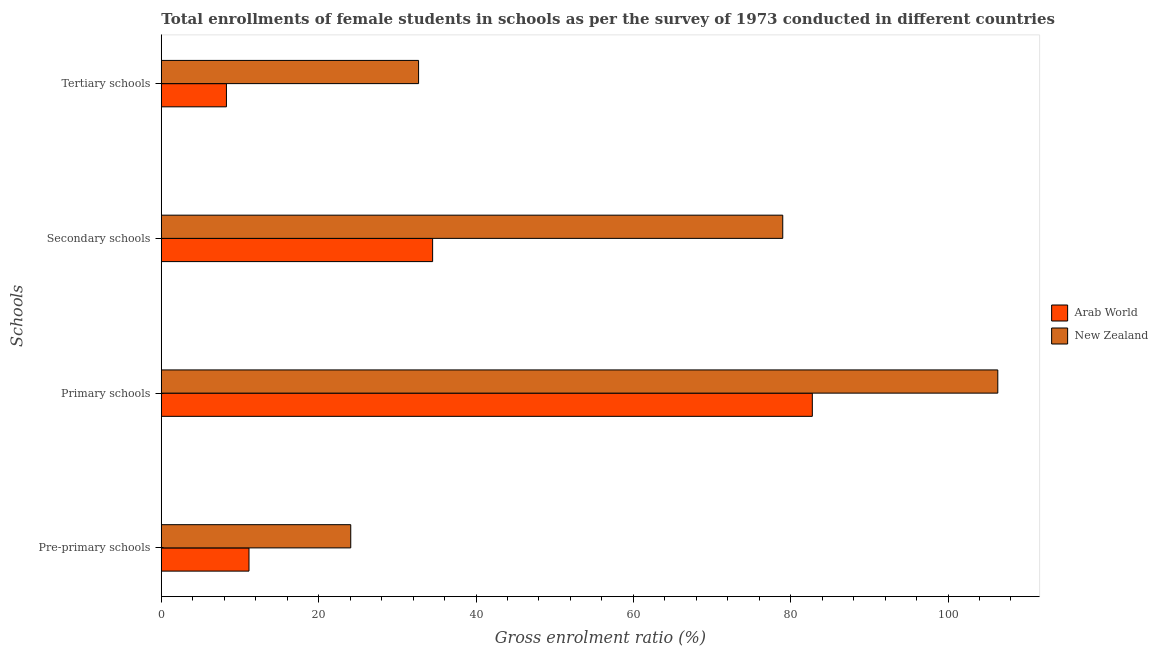Are the number of bars per tick equal to the number of legend labels?
Offer a very short reply. Yes. How many bars are there on the 4th tick from the top?
Your answer should be very brief. 2. What is the label of the 1st group of bars from the top?
Your answer should be compact. Tertiary schools. What is the gross enrolment ratio(female) in secondary schools in New Zealand?
Ensure brevity in your answer.  78.99. Across all countries, what is the maximum gross enrolment ratio(female) in primary schools?
Your response must be concise. 106.32. Across all countries, what is the minimum gross enrolment ratio(female) in secondary schools?
Keep it short and to the point. 34.49. In which country was the gross enrolment ratio(female) in tertiary schools maximum?
Your answer should be very brief. New Zealand. In which country was the gross enrolment ratio(female) in primary schools minimum?
Give a very brief answer. Arab World. What is the total gross enrolment ratio(female) in secondary schools in the graph?
Your answer should be compact. 113.47. What is the difference between the gross enrolment ratio(female) in primary schools in New Zealand and that in Arab World?
Your answer should be very brief. 23.57. What is the difference between the gross enrolment ratio(female) in tertiary schools in New Zealand and the gross enrolment ratio(female) in primary schools in Arab World?
Your answer should be compact. -50.05. What is the average gross enrolment ratio(female) in secondary schools per country?
Make the answer very short. 56.74. What is the difference between the gross enrolment ratio(female) in secondary schools and gross enrolment ratio(female) in pre-primary schools in Arab World?
Keep it short and to the point. 23.34. What is the ratio of the gross enrolment ratio(female) in pre-primary schools in Arab World to that in New Zealand?
Provide a short and direct response. 0.46. What is the difference between the highest and the second highest gross enrolment ratio(female) in pre-primary schools?
Provide a succinct answer. 12.93. What is the difference between the highest and the lowest gross enrolment ratio(female) in pre-primary schools?
Provide a short and direct response. 12.93. In how many countries, is the gross enrolment ratio(female) in tertiary schools greater than the average gross enrolment ratio(female) in tertiary schools taken over all countries?
Your response must be concise. 1. Is the sum of the gross enrolment ratio(female) in secondary schools in Arab World and New Zealand greater than the maximum gross enrolment ratio(female) in primary schools across all countries?
Keep it short and to the point. Yes. Is it the case that in every country, the sum of the gross enrolment ratio(female) in secondary schools and gross enrolment ratio(female) in tertiary schools is greater than the sum of gross enrolment ratio(female) in pre-primary schools and gross enrolment ratio(female) in primary schools?
Ensure brevity in your answer.  No. What does the 1st bar from the top in Primary schools represents?
Give a very brief answer. New Zealand. What does the 2nd bar from the bottom in Secondary schools represents?
Provide a short and direct response. New Zealand. Is it the case that in every country, the sum of the gross enrolment ratio(female) in pre-primary schools and gross enrolment ratio(female) in primary schools is greater than the gross enrolment ratio(female) in secondary schools?
Ensure brevity in your answer.  Yes. Are all the bars in the graph horizontal?
Your answer should be compact. Yes. Are the values on the major ticks of X-axis written in scientific E-notation?
Provide a short and direct response. No. How many legend labels are there?
Offer a very short reply. 2. How are the legend labels stacked?
Offer a very short reply. Vertical. What is the title of the graph?
Offer a very short reply. Total enrollments of female students in schools as per the survey of 1973 conducted in different countries. Does "Pacific island small states" appear as one of the legend labels in the graph?
Your answer should be compact. No. What is the label or title of the Y-axis?
Your response must be concise. Schools. What is the Gross enrolment ratio (%) in Arab World in Pre-primary schools?
Offer a very short reply. 11.15. What is the Gross enrolment ratio (%) in New Zealand in Pre-primary schools?
Make the answer very short. 24.08. What is the Gross enrolment ratio (%) in Arab World in Primary schools?
Your answer should be compact. 82.75. What is the Gross enrolment ratio (%) in New Zealand in Primary schools?
Offer a very short reply. 106.32. What is the Gross enrolment ratio (%) of Arab World in Secondary schools?
Make the answer very short. 34.49. What is the Gross enrolment ratio (%) of New Zealand in Secondary schools?
Offer a terse response. 78.99. What is the Gross enrolment ratio (%) of Arab World in Tertiary schools?
Your answer should be very brief. 8.28. What is the Gross enrolment ratio (%) of New Zealand in Tertiary schools?
Give a very brief answer. 32.7. Across all Schools, what is the maximum Gross enrolment ratio (%) in Arab World?
Provide a short and direct response. 82.75. Across all Schools, what is the maximum Gross enrolment ratio (%) of New Zealand?
Ensure brevity in your answer.  106.32. Across all Schools, what is the minimum Gross enrolment ratio (%) in Arab World?
Your answer should be compact. 8.28. Across all Schools, what is the minimum Gross enrolment ratio (%) in New Zealand?
Keep it short and to the point. 24.08. What is the total Gross enrolment ratio (%) in Arab World in the graph?
Make the answer very short. 136.66. What is the total Gross enrolment ratio (%) of New Zealand in the graph?
Provide a succinct answer. 242.09. What is the difference between the Gross enrolment ratio (%) of Arab World in Pre-primary schools and that in Primary schools?
Make the answer very short. -71.6. What is the difference between the Gross enrolment ratio (%) of New Zealand in Pre-primary schools and that in Primary schools?
Give a very brief answer. -82.24. What is the difference between the Gross enrolment ratio (%) of Arab World in Pre-primary schools and that in Secondary schools?
Your response must be concise. -23.34. What is the difference between the Gross enrolment ratio (%) in New Zealand in Pre-primary schools and that in Secondary schools?
Offer a very short reply. -54.91. What is the difference between the Gross enrolment ratio (%) in Arab World in Pre-primary schools and that in Tertiary schools?
Your response must be concise. 2.87. What is the difference between the Gross enrolment ratio (%) in New Zealand in Pre-primary schools and that in Tertiary schools?
Give a very brief answer. -8.62. What is the difference between the Gross enrolment ratio (%) of Arab World in Primary schools and that in Secondary schools?
Your answer should be compact. 48.26. What is the difference between the Gross enrolment ratio (%) in New Zealand in Primary schools and that in Secondary schools?
Ensure brevity in your answer.  27.33. What is the difference between the Gross enrolment ratio (%) of Arab World in Primary schools and that in Tertiary schools?
Keep it short and to the point. 74.47. What is the difference between the Gross enrolment ratio (%) in New Zealand in Primary schools and that in Tertiary schools?
Offer a terse response. 73.62. What is the difference between the Gross enrolment ratio (%) in Arab World in Secondary schools and that in Tertiary schools?
Offer a terse response. 26.21. What is the difference between the Gross enrolment ratio (%) of New Zealand in Secondary schools and that in Tertiary schools?
Make the answer very short. 46.29. What is the difference between the Gross enrolment ratio (%) of Arab World in Pre-primary schools and the Gross enrolment ratio (%) of New Zealand in Primary schools?
Keep it short and to the point. -95.18. What is the difference between the Gross enrolment ratio (%) of Arab World in Pre-primary schools and the Gross enrolment ratio (%) of New Zealand in Secondary schools?
Provide a succinct answer. -67.84. What is the difference between the Gross enrolment ratio (%) in Arab World in Pre-primary schools and the Gross enrolment ratio (%) in New Zealand in Tertiary schools?
Make the answer very short. -21.55. What is the difference between the Gross enrolment ratio (%) in Arab World in Primary schools and the Gross enrolment ratio (%) in New Zealand in Secondary schools?
Make the answer very short. 3.76. What is the difference between the Gross enrolment ratio (%) of Arab World in Primary schools and the Gross enrolment ratio (%) of New Zealand in Tertiary schools?
Keep it short and to the point. 50.05. What is the difference between the Gross enrolment ratio (%) in Arab World in Secondary schools and the Gross enrolment ratio (%) in New Zealand in Tertiary schools?
Provide a short and direct response. 1.78. What is the average Gross enrolment ratio (%) in Arab World per Schools?
Give a very brief answer. 34.16. What is the average Gross enrolment ratio (%) in New Zealand per Schools?
Make the answer very short. 60.52. What is the difference between the Gross enrolment ratio (%) of Arab World and Gross enrolment ratio (%) of New Zealand in Pre-primary schools?
Your answer should be compact. -12.93. What is the difference between the Gross enrolment ratio (%) of Arab World and Gross enrolment ratio (%) of New Zealand in Primary schools?
Your answer should be very brief. -23.57. What is the difference between the Gross enrolment ratio (%) of Arab World and Gross enrolment ratio (%) of New Zealand in Secondary schools?
Ensure brevity in your answer.  -44.5. What is the difference between the Gross enrolment ratio (%) of Arab World and Gross enrolment ratio (%) of New Zealand in Tertiary schools?
Your answer should be compact. -24.42. What is the ratio of the Gross enrolment ratio (%) of Arab World in Pre-primary schools to that in Primary schools?
Your response must be concise. 0.13. What is the ratio of the Gross enrolment ratio (%) of New Zealand in Pre-primary schools to that in Primary schools?
Give a very brief answer. 0.23. What is the ratio of the Gross enrolment ratio (%) in Arab World in Pre-primary schools to that in Secondary schools?
Provide a short and direct response. 0.32. What is the ratio of the Gross enrolment ratio (%) in New Zealand in Pre-primary schools to that in Secondary schools?
Your answer should be very brief. 0.3. What is the ratio of the Gross enrolment ratio (%) of Arab World in Pre-primary schools to that in Tertiary schools?
Your answer should be very brief. 1.35. What is the ratio of the Gross enrolment ratio (%) of New Zealand in Pre-primary schools to that in Tertiary schools?
Your response must be concise. 0.74. What is the ratio of the Gross enrolment ratio (%) in Arab World in Primary schools to that in Secondary schools?
Offer a very short reply. 2.4. What is the ratio of the Gross enrolment ratio (%) in New Zealand in Primary schools to that in Secondary schools?
Make the answer very short. 1.35. What is the ratio of the Gross enrolment ratio (%) of Arab World in Primary schools to that in Tertiary schools?
Your answer should be compact. 10. What is the ratio of the Gross enrolment ratio (%) of New Zealand in Primary schools to that in Tertiary schools?
Your response must be concise. 3.25. What is the ratio of the Gross enrolment ratio (%) in Arab World in Secondary schools to that in Tertiary schools?
Make the answer very short. 4.17. What is the ratio of the Gross enrolment ratio (%) in New Zealand in Secondary schools to that in Tertiary schools?
Give a very brief answer. 2.42. What is the difference between the highest and the second highest Gross enrolment ratio (%) in Arab World?
Provide a succinct answer. 48.26. What is the difference between the highest and the second highest Gross enrolment ratio (%) in New Zealand?
Ensure brevity in your answer.  27.33. What is the difference between the highest and the lowest Gross enrolment ratio (%) in Arab World?
Ensure brevity in your answer.  74.47. What is the difference between the highest and the lowest Gross enrolment ratio (%) in New Zealand?
Provide a short and direct response. 82.24. 